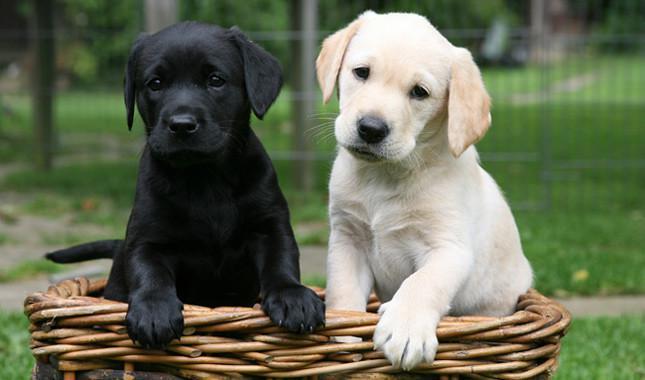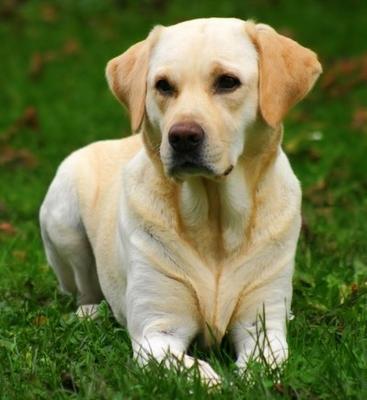The first image is the image on the left, the second image is the image on the right. Examine the images to the left and right. Is the description "There are two dogs" accurate? Answer yes or no. No. 